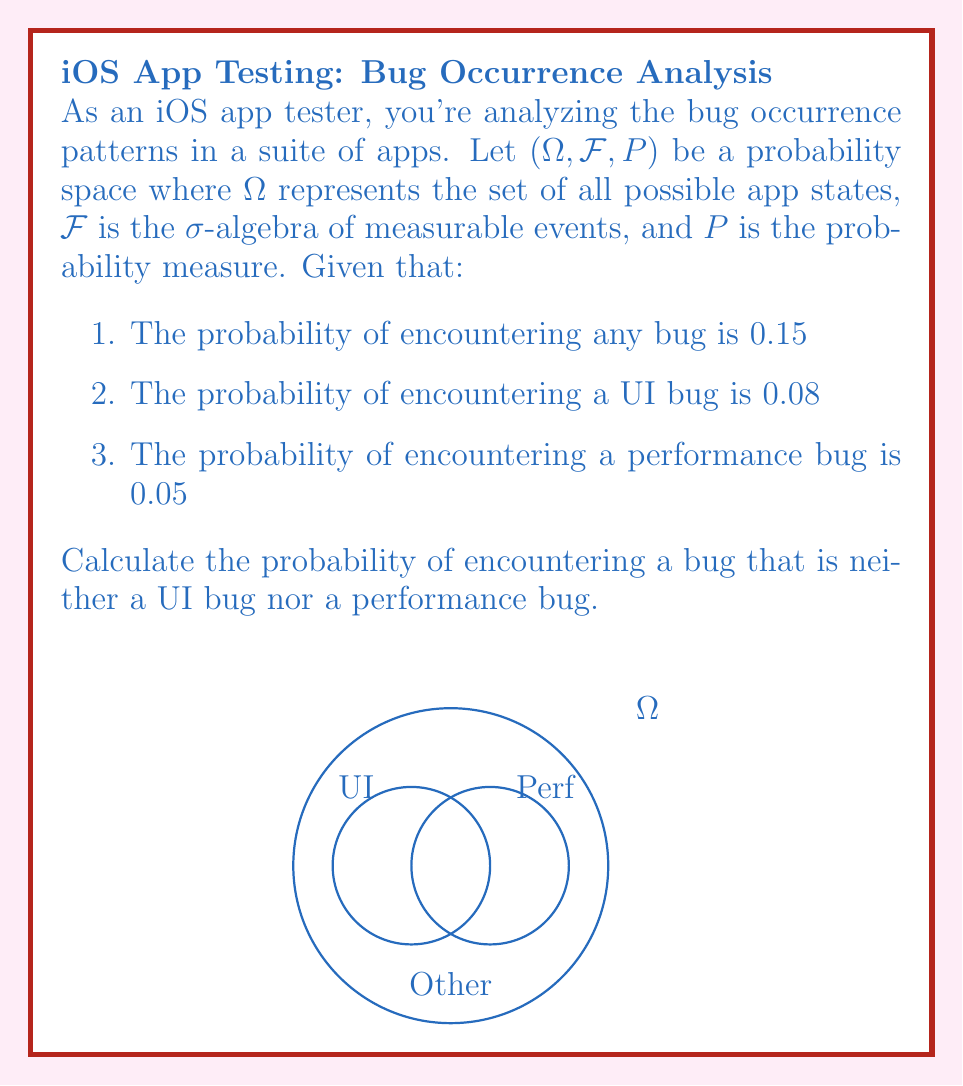Solve this math problem. Let's approach this step-by-step using measure theory concepts:

1) Define the events:
   $A$: encountering any bug
   $B$: encountering a UI bug
   $C$: encountering a performance bug

2) Given probabilities:
   $P(A) = 0.15$
   $P(B) = 0.08$
   $P(C) = 0.05$

3) We want to find $P(A \setminus (B \cup C))$, which represents the probability of encountering a bug that is neither UI nor performance related.

4) Using the inclusion-exclusion principle:
   $P(A) = P(B) + P(C) + P(A \setminus (B \cup C)) - P(B \cap C)$

5) Rearranging the equation:
   $P(A \setminus (B \cup C)) = P(A) - P(B) - P(C) + P(B \cap C)$

6) We don't know $P(B \cap C)$, but we know it's non-negative. So:
   $P(A \setminus (B \cup C)) \geq P(A) - P(B) - P(C)$

7) Substituting the known values:
   $P(A \setminus (B \cup C)) \geq 0.15 - 0.08 - 0.05 = 0.02$

8) This is the lower bound. The upper bound is simply $P(A) = 0.15$, as the probability can't be higher than encountering any bug.

Therefore, the probability of encountering a bug that is neither UI nor performance related is at least 0.02 and at most 0.15.
Answer: $[0.02, 0.15]$ 